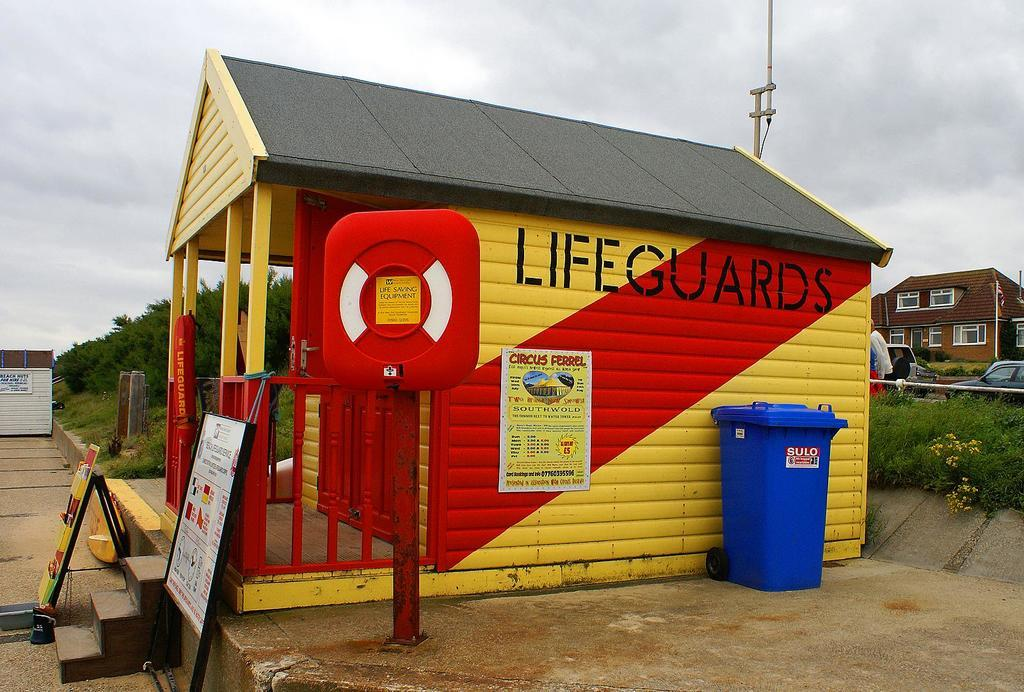<image>
Provide a brief description of the given image. A lifeguard station is painted yellow with a red stripe. 